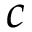Convert formula to latex. <formula><loc_0><loc_0><loc_500><loc_500>c</formula> 